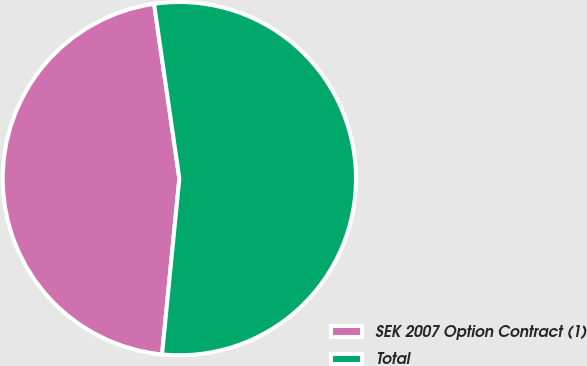<chart> <loc_0><loc_0><loc_500><loc_500><pie_chart><fcel>SEK 2007 Option Contract (1)<fcel>Total<nl><fcel>46.15%<fcel>53.85%<nl></chart> 